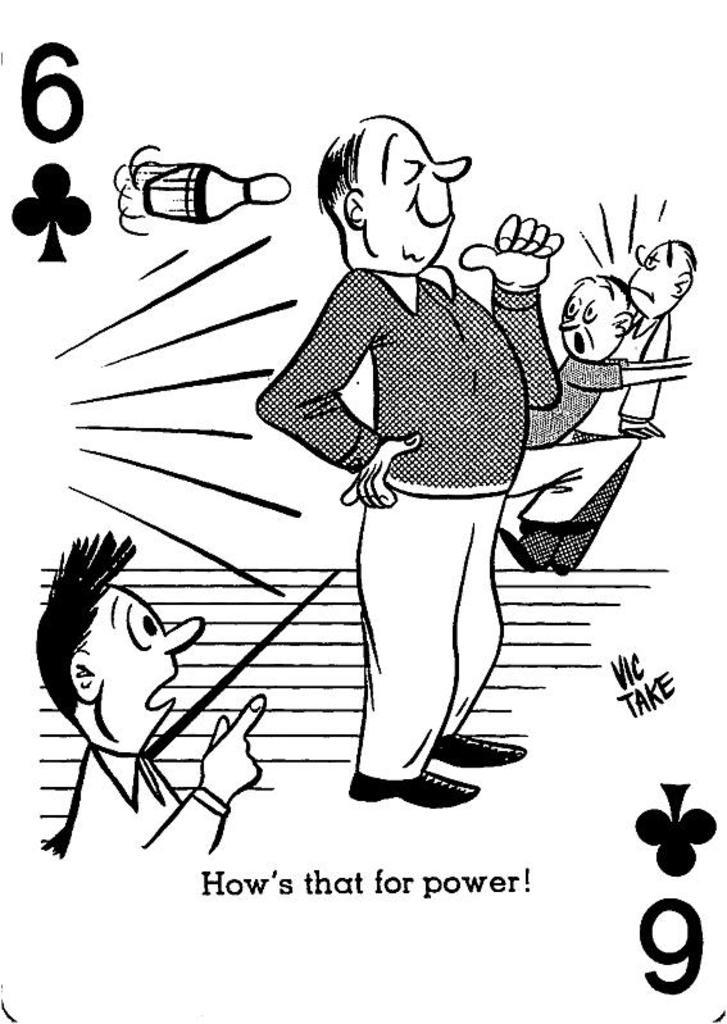What type of image is depicted in the picture? The image contains a cartoon image of people. Is there any text present in the image? Yes, there is text written on the image. What color scheme is used for the image? The image is black and white in color. Can you tell me what type of guitar is being played by the mother in the image? There is no mother or guitar present in the image; it contains a cartoon image of people and text, and the color scheme is black and white. 